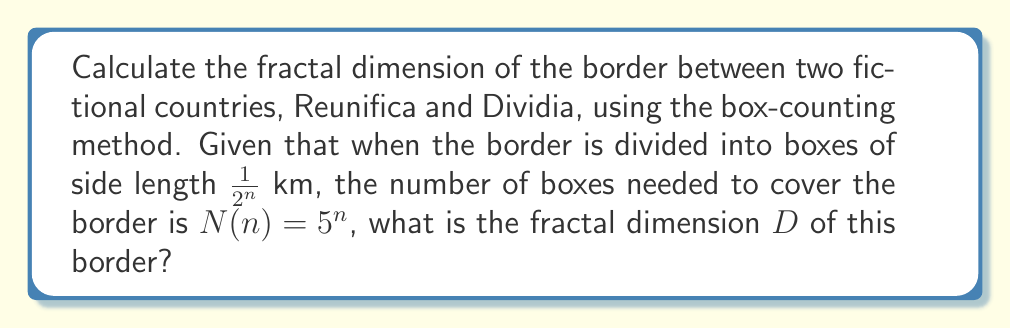Solve this math problem. To solve this problem, we'll use the box-counting method to determine the fractal dimension. This method is particularly relevant for analyzing complex border patterns, which could symbolize the challenges in reuniting a divided family.

Step 1: Recall the formula for fractal dimension using the box-counting method:
$$D = \lim_{n \to \infty} \frac{\log N(n)}{\log(2^n)}$$

Where $N(n)$ is the number of boxes of side length $\frac{1}{2^n}$ needed to cover the fractal.

Step 2: Substitute the given information into the formula:
$$D = \lim_{n \to \infty} \frac{\log(5^n)}{\log(2^n)}$$

Step 3: Use the logarithm property $\log(a^n) = n\log(a)$:
$$D = \lim_{n \to \infty} \frac{n\log(5)}{n\log(2)}$$

Step 4: The $n$ cancels out in the numerator and denominator:
$$D = \frac{\log(5)}{\log(2)}$$

Step 5: Calculate the final value:
$$D \approx 2.3219$$

This fractal dimension between 2 and 3 indicates a highly complex and irregular border, which could represent the intricate challenges in overcoming border differences to reunite a family.
Answer: $\frac{\log(5)}{\log(2)} \approx 2.3219$ 